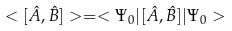Convert formula to latex. <formula><loc_0><loc_0><loc_500><loc_500>< [ { \hat { A } } , { \hat { B } } ] > = < \Psi _ { 0 } | [ { \hat { A } } , { \hat { B } } ] | \Psi _ { 0 } ></formula> 